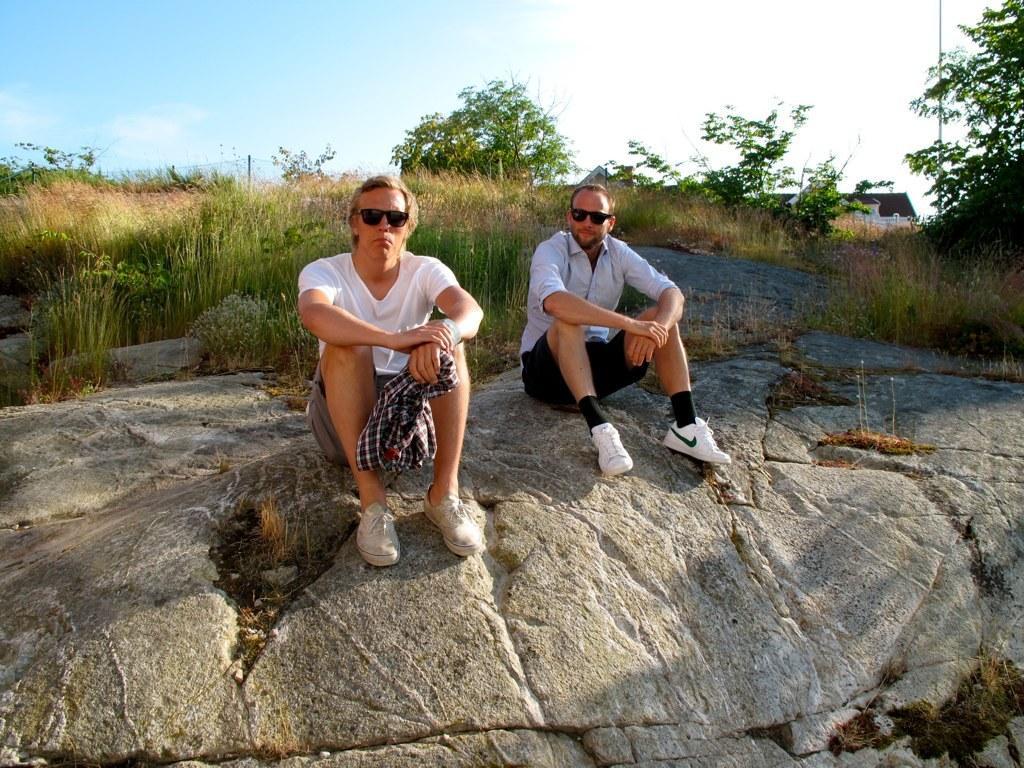Could you give a brief overview of what you see in this image? This image is taken outdoors. At the top of the image there is the sky with clouds. At the bottom of the image there is a rock. In the middle of the image two men are sitting on the rock. In the background there are many plants and a few trees on the ground and there is a ground with grass on it. 